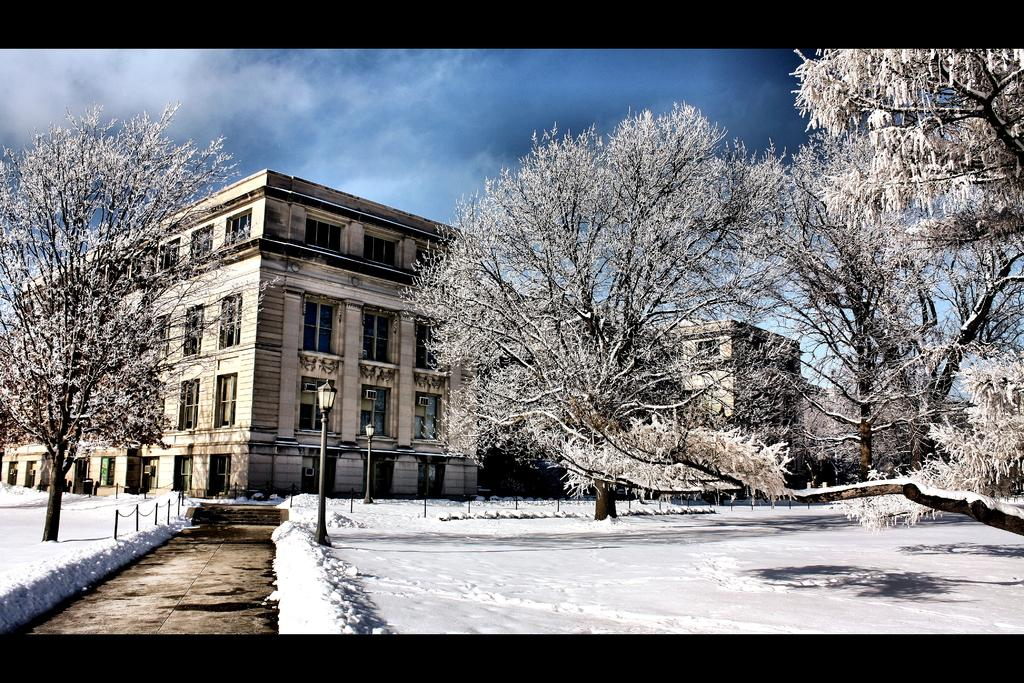What can be seen running through the trees in the image? There is a path in the image that runs between trees. What structure is located in the middle of the image? There is a building in the middle of the image. What is present beside the path in the image? There is a pole beside the path in the image. What is visible at the top of the image? The sky is visible at the top of the image. What type of breakfast is being served in the image? There is no breakfast or meal present in the image; it features a path, trees, a building, a pole, and the sky. What industry is depicted in the image? The image does not depict any specific industry; it shows a path, trees, a building, a pole, and the sky. 